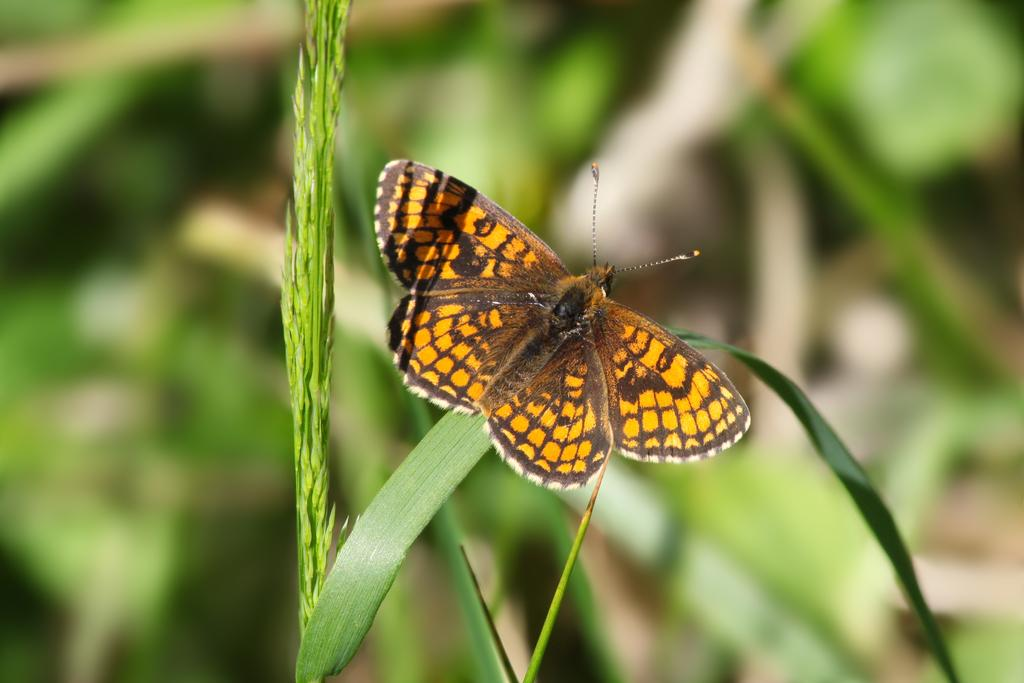What is the main subject of the image? There is a butterfly in the image. Where is the butterfly located? The butterfly is on a leaf of a plant. Can you describe the background of the image? The background of the image is blurry. What class is the butterfly attending in the image? There is no indication in the image that the butterfly is attending a class, as butterflies do not attend classes. 